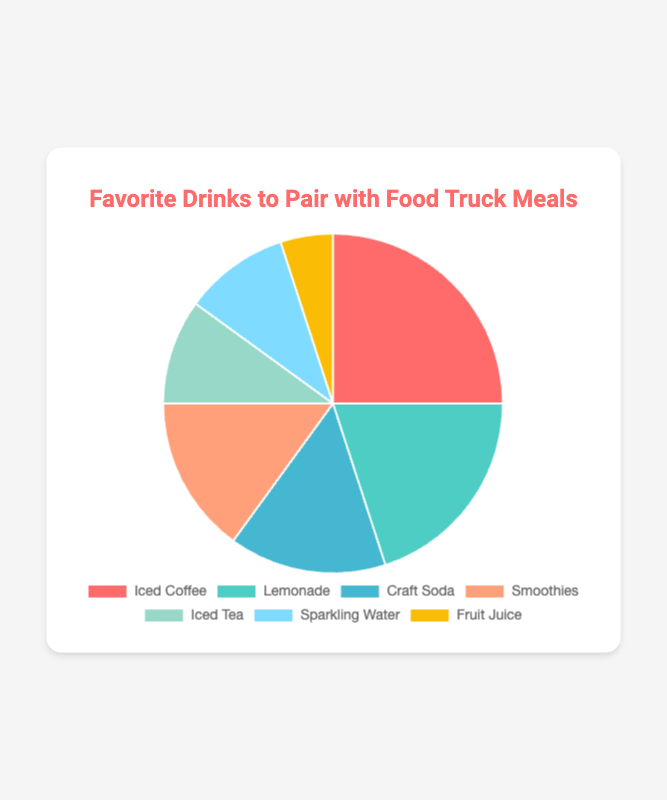What is the most preferred drink among office workers to pair with food truck meals? The chart shows different percentage slices for each drink. The largest slice represents the most preferred drink. The drink with the highest percentage is Iced Coffee at 25%.
Answer: Iced Coffee Which drink has a smaller percentage, Sparkling Water or Fruit Juice? The slices for Sparkling Water and Fruit Juice can be compared visually. Sparkling Water has 10%, whereas Fruit Juice has 5%. Since 10% is larger than 5%, Fruit Juice has a smaller percentage.
Answer: Fruit Juice What is the total percentage of office workers who prefer either Craft Soda or Smoothies? To find the total percentage, sum the percentages of Craft Soda and Smoothies. Both have a percentage of 15%. So, 15% + 15% = 30%.
Answer: 30% How does the percentage of office workers who prefer Iced Tea compare to those who prefer Lemonade? By comparing the slices directly, Iced Tea has 10%, and Lemonade has 20%. Since 10% is less than 20%, fewer workers prefer Iced Tea compared to Lemonade.
Answer: Less What is the average percentage of office workers who prefer Iced Tea, Sparkling Water, and Fruit Juice? To find the average, sum the percentages of Iced Tea, Sparkling Water, and Fruit Juice and then divide by the number of drinks. (10% + 10% + 5%) / 3 = 25% / 3 ≈ 8.33%.
Answer: 8.33% Which drink category is represented by the yellow slice in the pie chart? By observing the color of the slices in the chart, the yellow slice corresponds to the label "Fruit Juice," as it has a 5% section.
Answer: Fruit Juice Is the combined preference for Smoothies and Craft Soda more than the preference for Iced Coffee? Combine the percentages for Smoothies and Craft Soda: 15% + 15% = 30%. Iced Coffee has 25%. Since 30% is more than 25%, the combined preference for Smoothies and Craft Soda is higher.
Answer: Yes How much more percentage do office workers prefer Lemonade over Smoothies? Calculate the difference between the percentages of Lemonade and Smoothies. Lemonade is 20%, and Smoothies are 15%. 20% - 15% = 5%.
Answer: 5% What proportion of office workers prefer either Smoothies or Iced Tea out of the total sample? Add the percentages for Smoothies and Iced Tea to find their combined proportion. 15% (Smoothies) + 10% (Iced Tea) = 25%.
Answer: 25% Which two drinks have an equal percentage of preference among office workers? From the chart, the slices for Craft Soda and Smoothies each represent 15%. Both have the same percentage of preference.
Answer: Craft Soda and Smoothies 